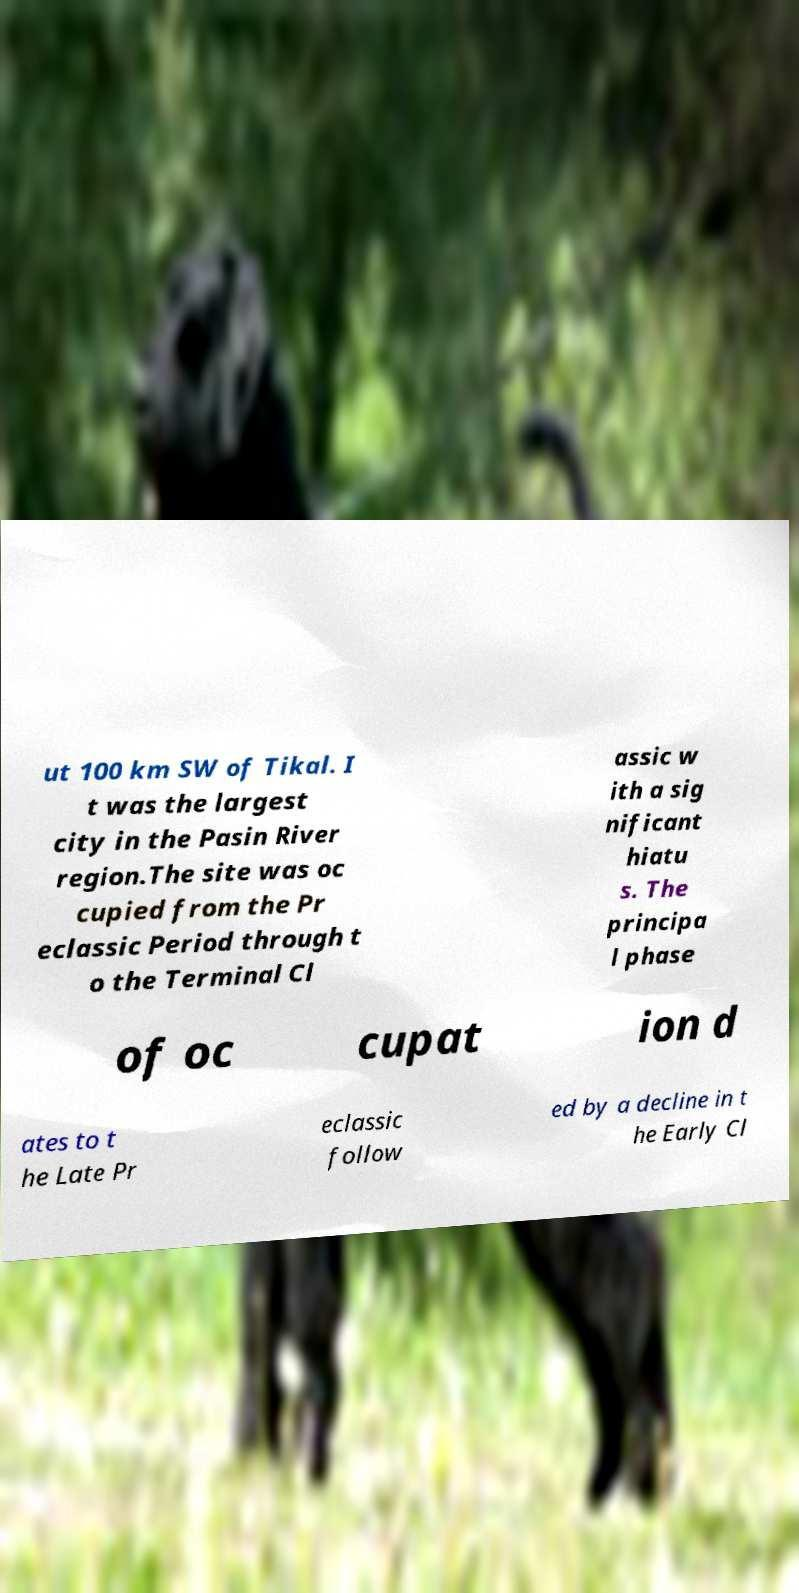Could you extract and type out the text from this image? ut 100 km SW of Tikal. I t was the largest city in the Pasin River region.The site was oc cupied from the Pr eclassic Period through t o the Terminal Cl assic w ith a sig nificant hiatu s. The principa l phase of oc cupat ion d ates to t he Late Pr eclassic follow ed by a decline in t he Early Cl 